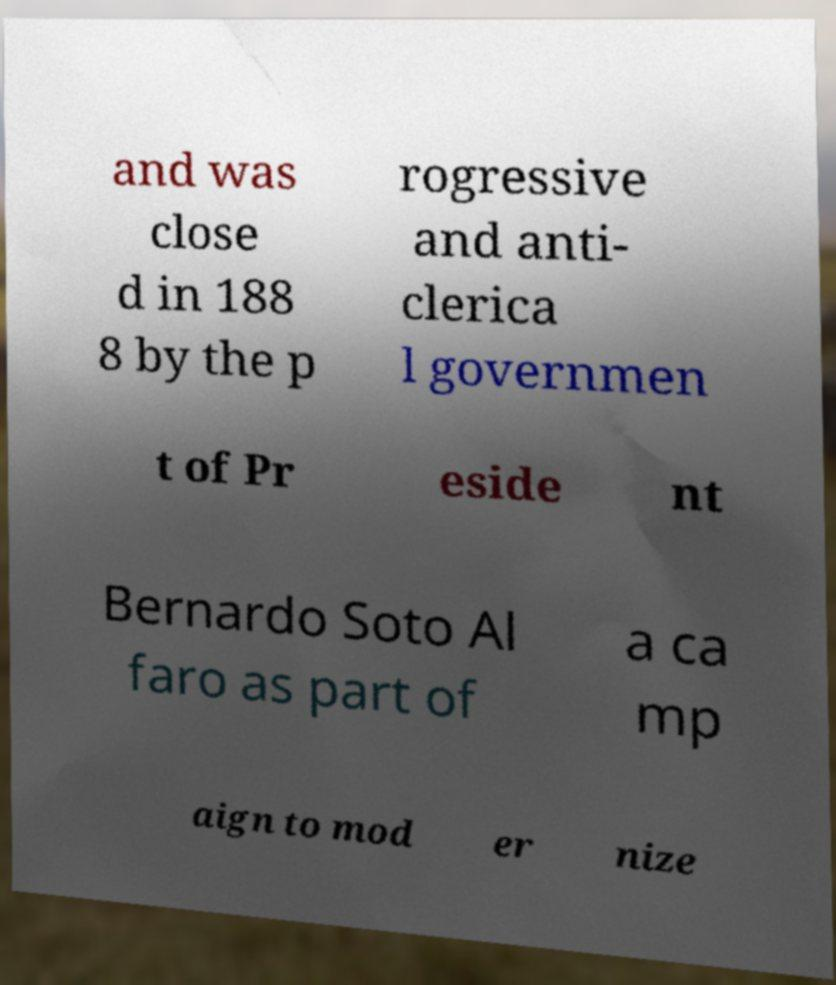For documentation purposes, I need the text within this image transcribed. Could you provide that? and was close d in 188 8 by the p rogressive and anti- clerica l governmen t of Pr eside nt Bernardo Soto Al faro as part of a ca mp aign to mod er nize 